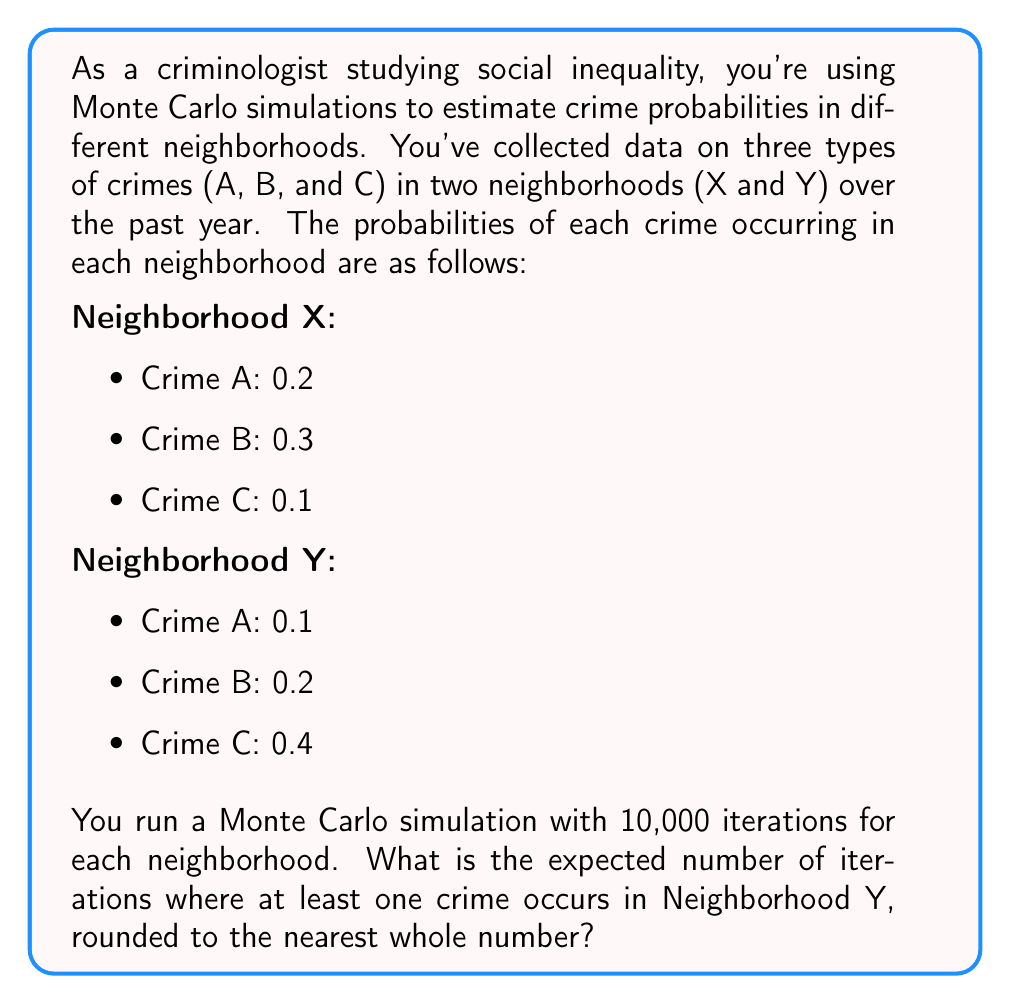Solve this math problem. To solve this problem, we'll follow these steps:

1) First, we need to calculate the probability that no crime occurs in Neighborhood Y. This is the complement of at least one crime occurring.

2) The probability of no crime occurring is the product of the probabilities of each crime not occurring:

   $P(\text{no crime}) = (1-0.1) \times (1-0.2) \times (1-0.4) = 0.9 \times 0.8 \times 0.6 = 0.432$

3) Therefore, the probability of at least one crime occurring is:

   $P(\text{at least one crime}) = 1 - P(\text{no crime}) = 1 - 0.432 = 0.568$

4) In a Monte Carlo simulation with 10,000 iterations, the expected number of iterations where at least one crime occurs is:

   $E(\text{iterations with crime}) = 10000 \times 0.568 = 5680$

5) Rounding to the nearest whole number:

   $5680 \approx 5680$

Thus, we expect approximately 5680 iterations out of 10,000 to have at least one crime occur in Neighborhood Y.
Answer: 5680 